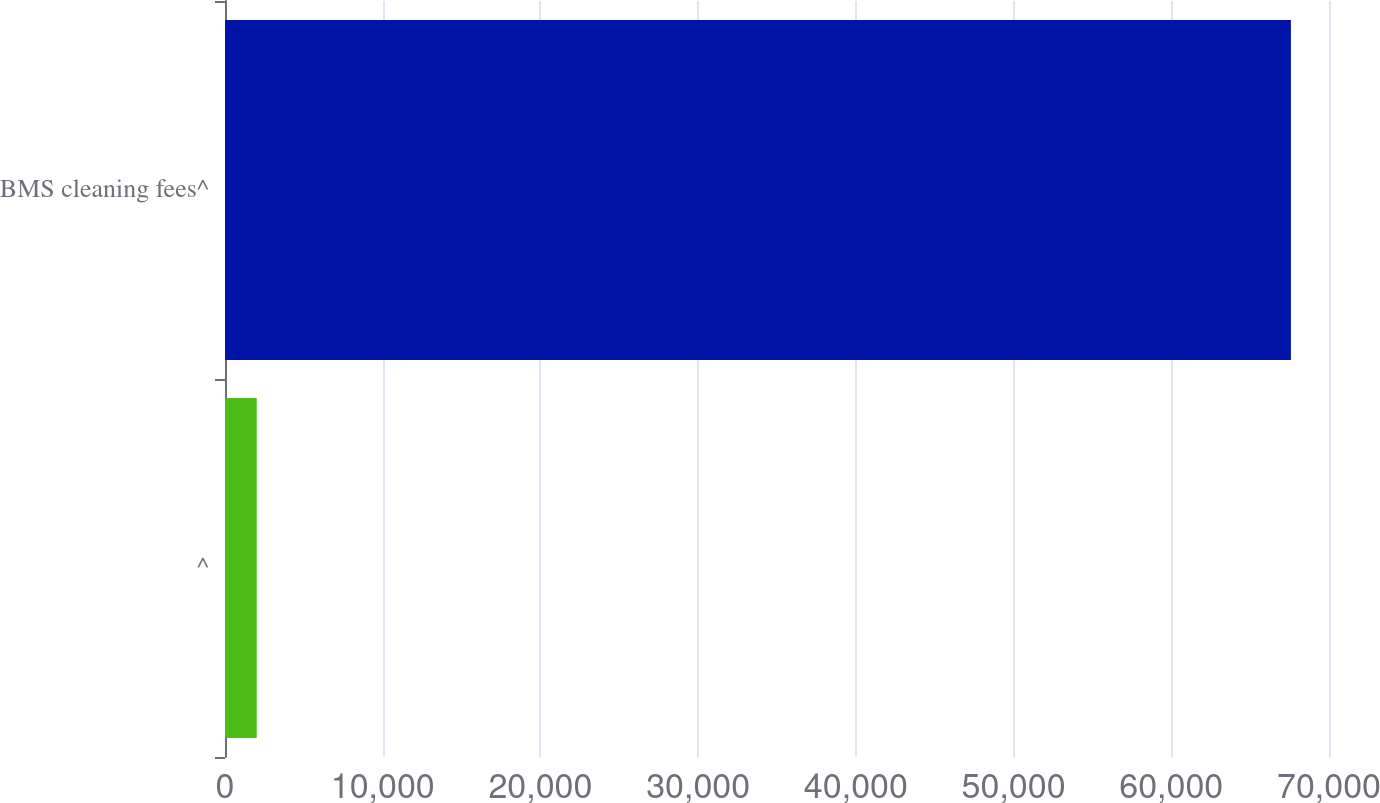Convert chart. <chart><loc_0><loc_0><loc_500><loc_500><bar_chart><fcel>^<fcel>BMS cleaning fees^<nl><fcel>2012<fcel>67584<nl></chart> 